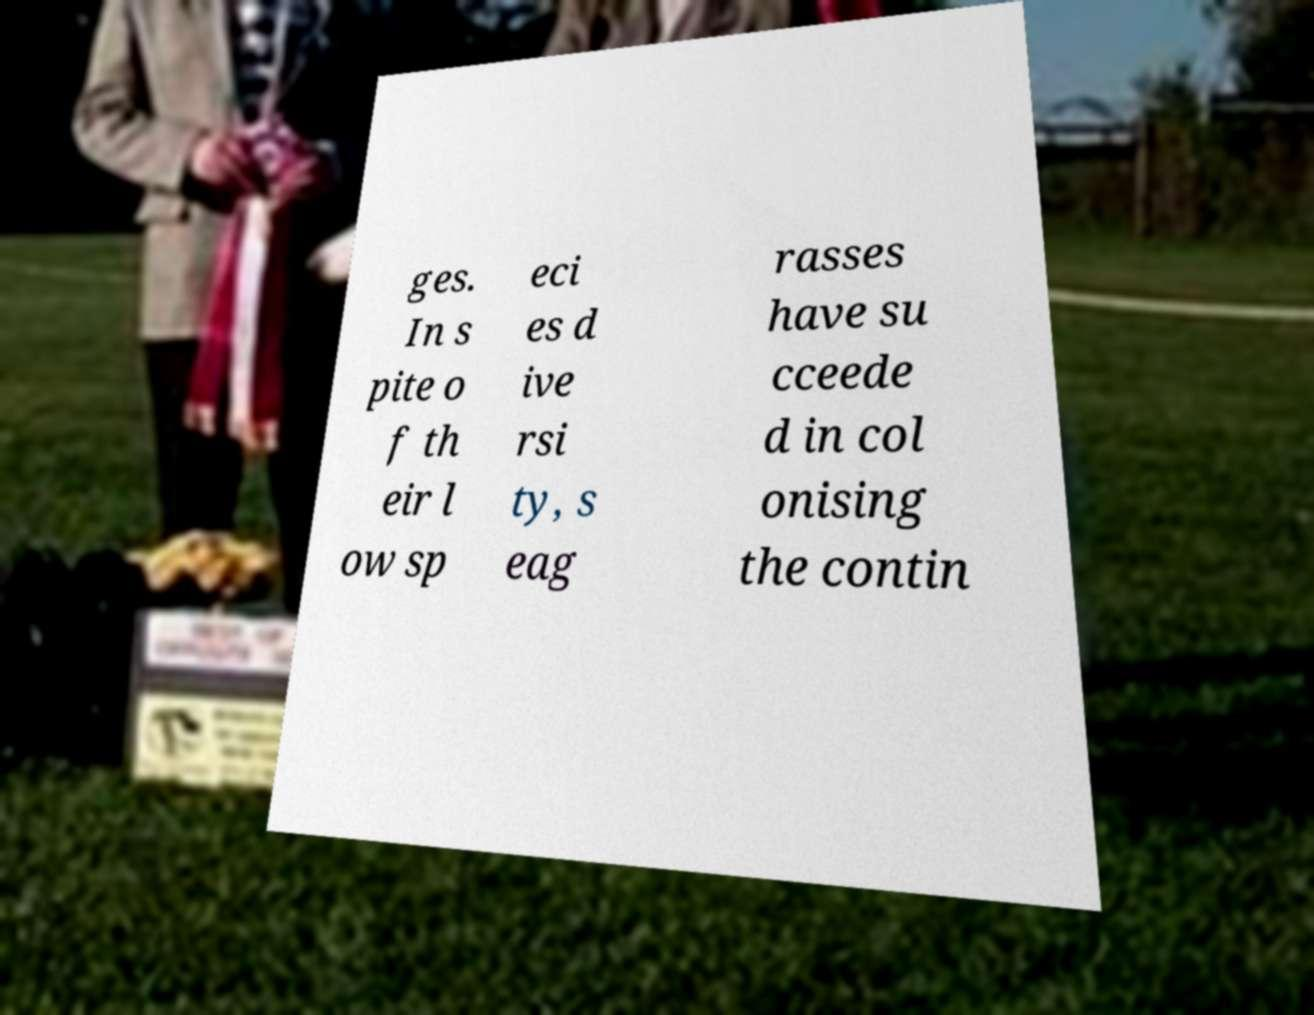Could you extract and type out the text from this image? ges. In s pite o f th eir l ow sp eci es d ive rsi ty, s eag rasses have su cceede d in col onising the contin 